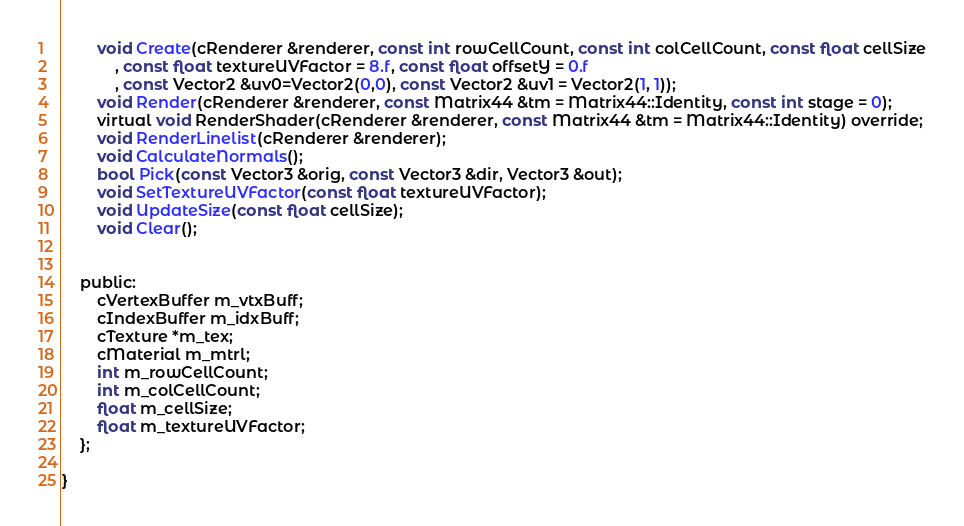<code> <loc_0><loc_0><loc_500><loc_500><_C_>
		void Create(cRenderer &renderer, const int rowCellCount, const int colCellCount, const float cellSize
			, const float textureUVFactor = 8.f, const float offsetY = 0.f
			, const Vector2 &uv0=Vector2(0,0), const Vector2 &uv1 = Vector2(1, 1));
		void Render(cRenderer &renderer, const Matrix44 &tm = Matrix44::Identity, const int stage = 0);
		virtual void RenderShader(cRenderer &renderer, const Matrix44 &tm = Matrix44::Identity) override;
		void RenderLinelist(cRenderer &renderer);
		void CalculateNormals();
		bool Pick(const Vector3 &orig, const Vector3 &dir, Vector3 &out);
		void SetTextureUVFactor(const float textureUVFactor);
		void UpdateSize(const float cellSize);
		void Clear();


	public:
		cVertexBuffer m_vtxBuff;
		cIndexBuffer m_idxBuff;
		cTexture *m_tex;
		cMaterial m_mtrl;
		int m_rowCellCount;
		int m_colCellCount;
		float m_cellSize;
		float m_textureUVFactor;
	};
	
}
</code> 